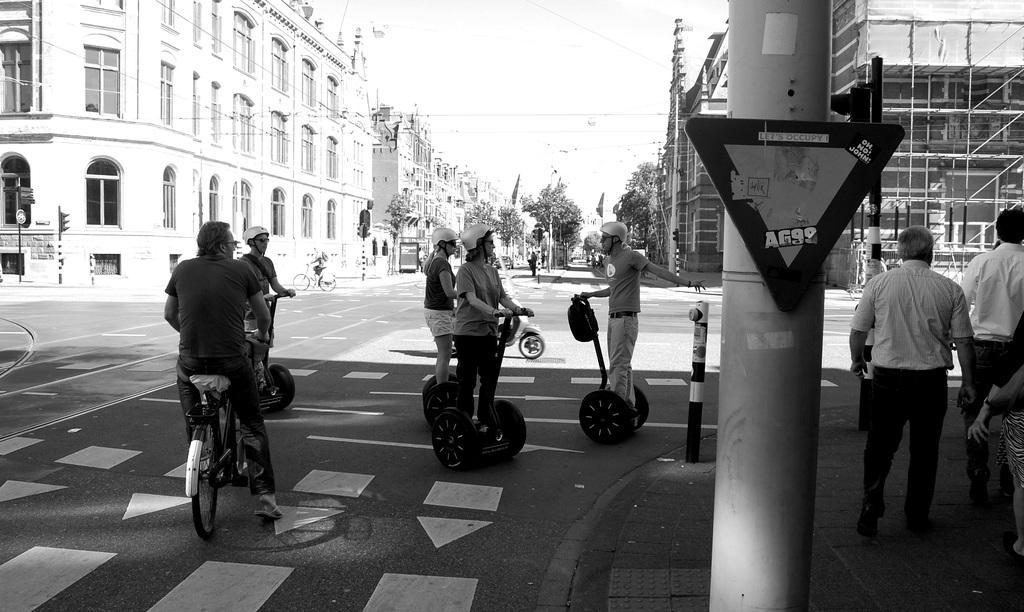In one or two sentences, can you explain what this image depicts? In the middle and bottom, there are group of people standing, riding a bicycle and a vehicle. In the top left and right buildings are visible. In the top middle, a sky is there of white in color. Below that trees are visible. This image is taken during day time on the road. 